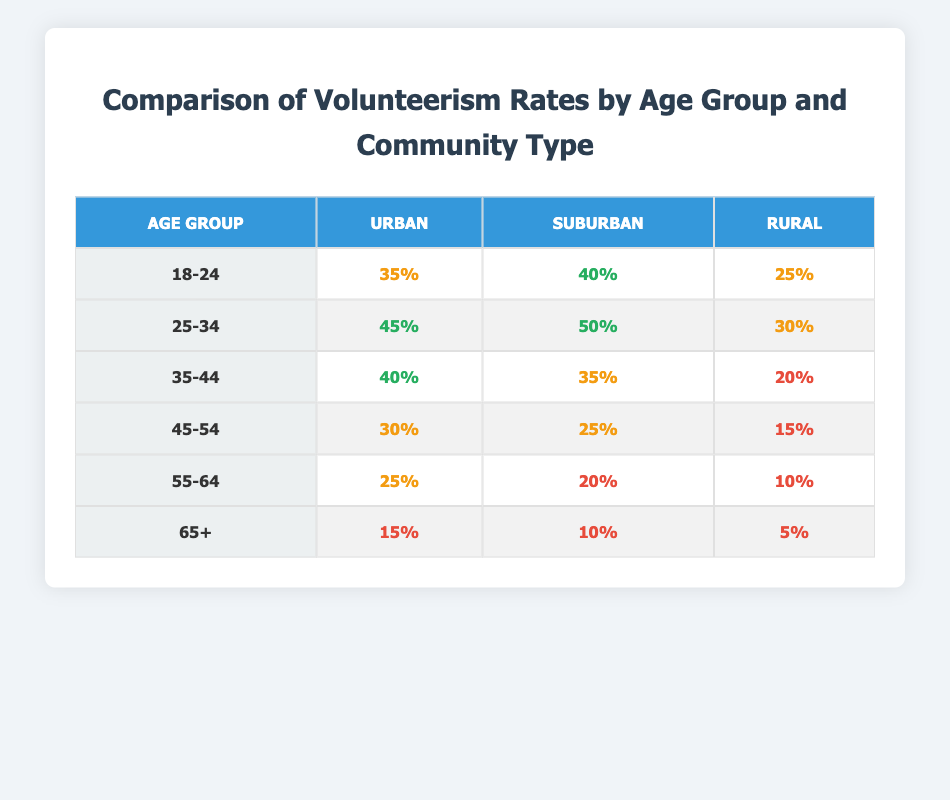What is the volunteerism rate for the age group 25-34 in suburban communities? Referring to the table, under the age group 25-34 and the suburban column, the rate is listed as 50%.
Answer: 50% Which age group has the highest volunteerism rate in urban areas? Looking at the urban column, the age group 25-34 has the highest rate of 45%, compared to other age groups listed.
Answer: 25-34 What is the difference in volunteerism rates between the rural and urban communities for the age group 45-54? For age group 45-54, the rates are 15% for rural and 30% for urban. The difference is 30% - 15% = 15%.
Answer: 15% Is the volunteerism rate for age group 35-44 higher in suburban areas than in rural areas? In the suburban area, the rate for 35-44 is 35%, and in the rural area, it is 20%, so 35% is indeed greater than 20%.
Answer: Yes What is the average volunteerism rate across all community types for the age group 55-64? For age group 55-64, the rates are 25% (urban), 20% (suburban), and 10% (rural). The average is (25 + 20 + 10) / 3 = 55 / 3 = approximately 18.33%.
Answer: 18.33% What is the total volunteerism rate for the age group 65+ across all community types? Summing the rates for age group 65+ gives us 15% (urban) + 10% (suburban) + 5% (rural) = 30%.
Answer: 30% Does the volunteerism rate decrease for the age group 45-54 when comparing urban to rural areas? Yes, the rate in urban areas is 30%, while in rural areas, it is 15%, indicating a decrease.
Answer: Yes Which community type shows the lowest volunteerism rate for the age group 18-24? The rural community type shows the lowest rate at 25% among the 18-24 age group listed in the table.
Answer: Rural 